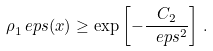<formula> <loc_0><loc_0><loc_500><loc_500>\rho _ { 1 } ^ { \ } e p s ( x ) \geq \exp \left [ - \frac { C _ { 2 } } { \ e p s ^ { 2 } } \right ] \, .</formula> 